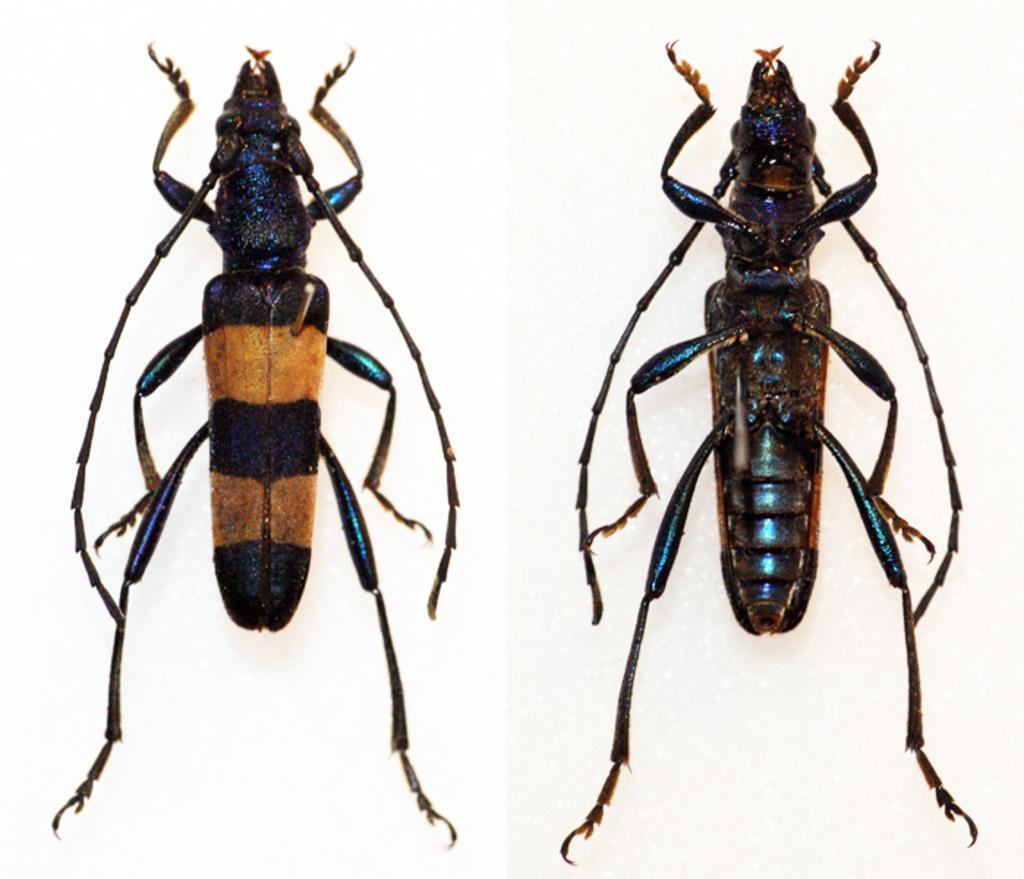What type of artwork is depicted in the image? The image is a collage. Can you identify any living organisms in the image? Yes, there are two insects in the image. What color is the background of the image? The background of the image is white. Are the insects fighting with each other in the image? There is no indication in the image that the insects are fighting with each other. 